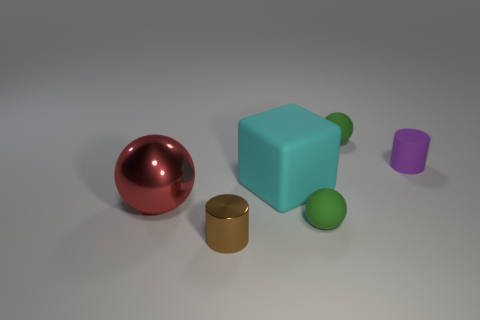Subtract all small green spheres. How many spheres are left? 1 Add 3 large cyan objects. How many objects exist? 9 Subtract all cubes. How many objects are left? 5 Subtract all tiny green spheres. Subtract all brown cylinders. How many objects are left? 3 Add 5 big red balls. How many big red balls are left? 6 Add 3 small things. How many small things exist? 7 Subtract 0 blue balls. How many objects are left? 6 